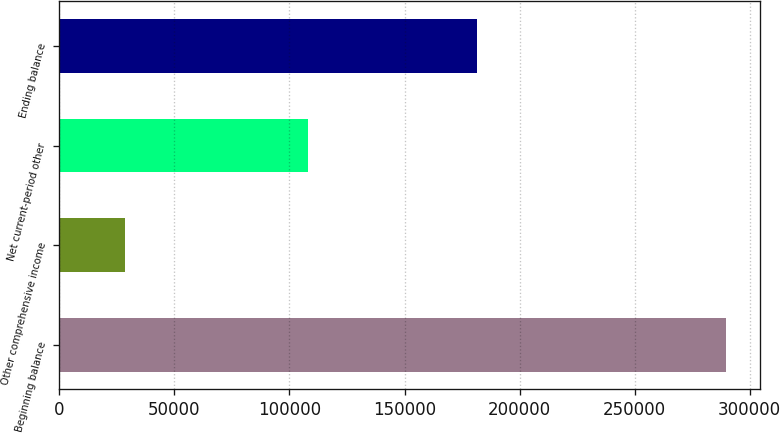Convert chart. <chart><loc_0><loc_0><loc_500><loc_500><bar_chart><fcel>Beginning balance<fcel>Other comprehensive income<fcel>Net current-period other<fcel>Ending balance<nl><fcel>289866<fcel>28646<fcel>108160<fcel>181706<nl></chart> 